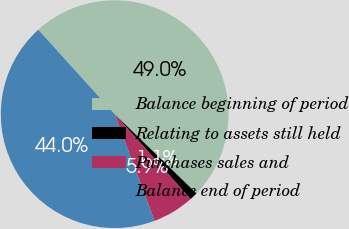<chart> <loc_0><loc_0><loc_500><loc_500><pie_chart><fcel>Balance beginning of period<fcel>Relating to assets still held<fcel>Purchases sales and<fcel>Balance end of period<nl><fcel>48.96%<fcel>1.14%<fcel>5.92%<fcel>43.99%<nl></chart> 